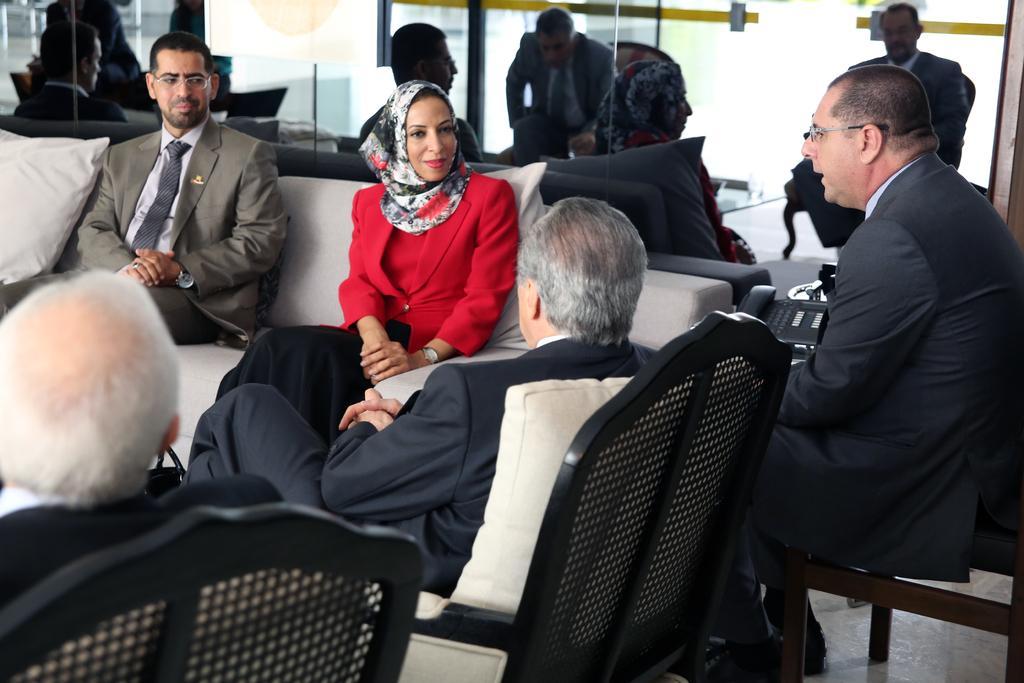Please provide a concise description of this image. In the image we can see there are people who are sitting on sofa and a chair. 